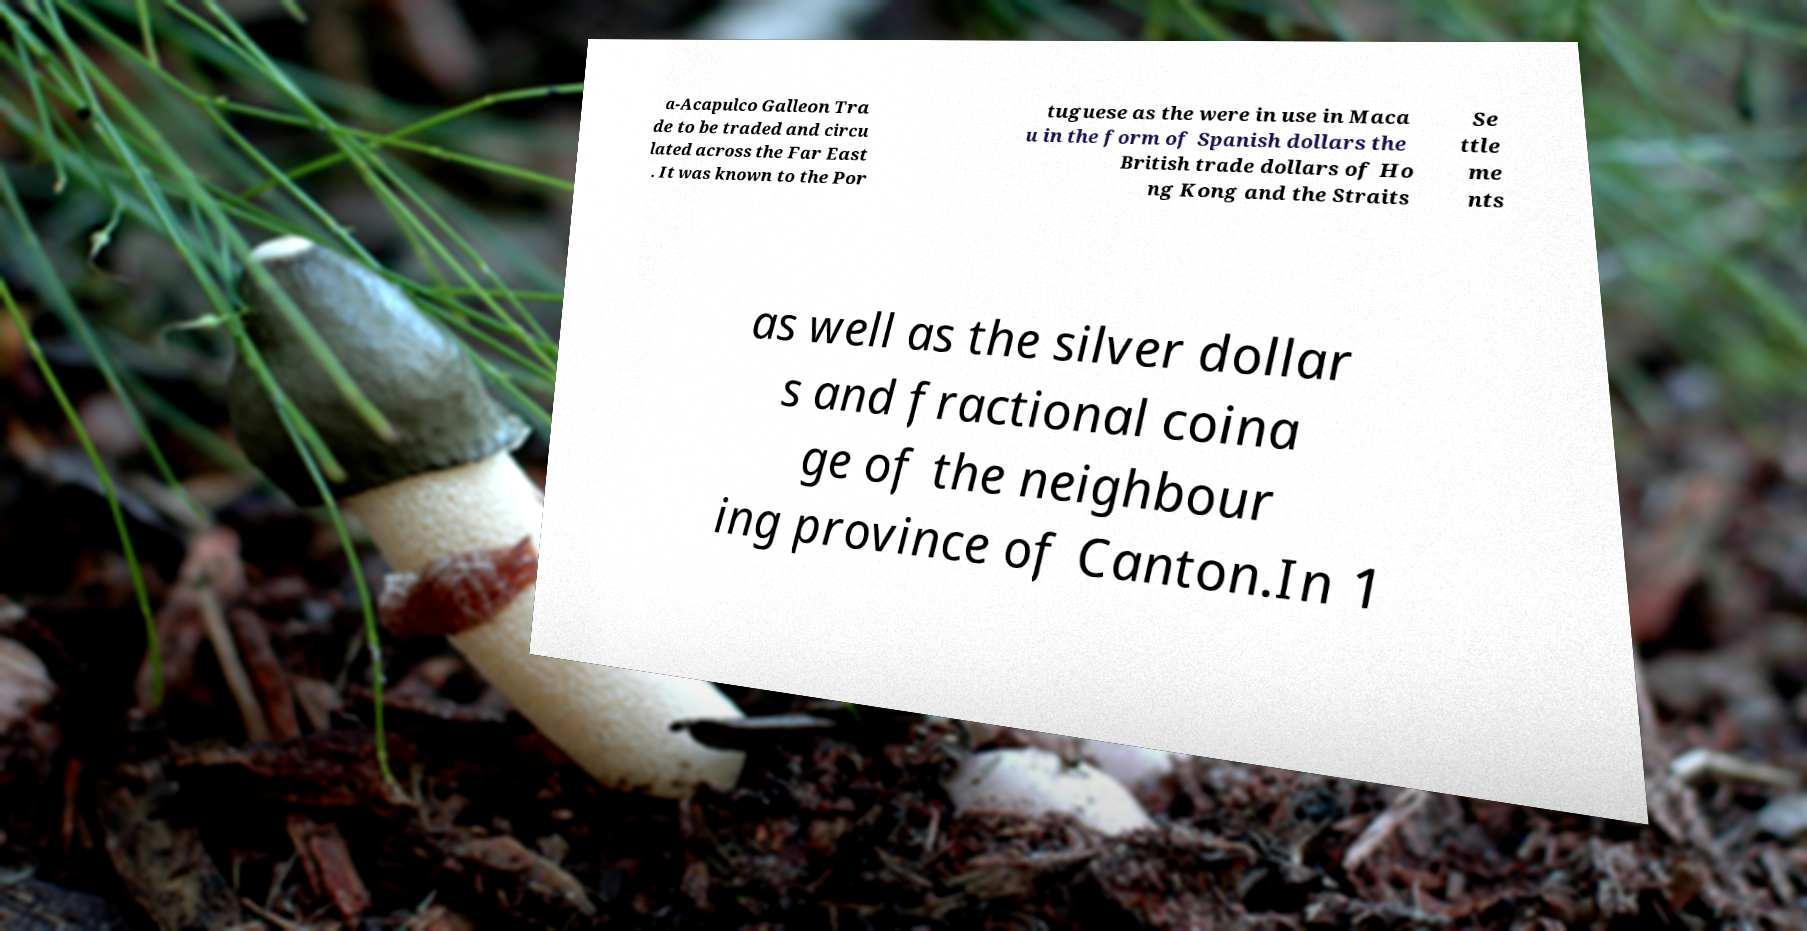Can you read and provide the text displayed in the image?This photo seems to have some interesting text. Can you extract and type it out for me? a-Acapulco Galleon Tra de to be traded and circu lated across the Far East . It was known to the Por tuguese as the were in use in Maca u in the form of Spanish dollars the British trade dollars of Ho ng Kong and the Straits Se ttle me nts as well as the silver dollar s and fractional coina ge of the neighbour ing province of Canton.In 1 